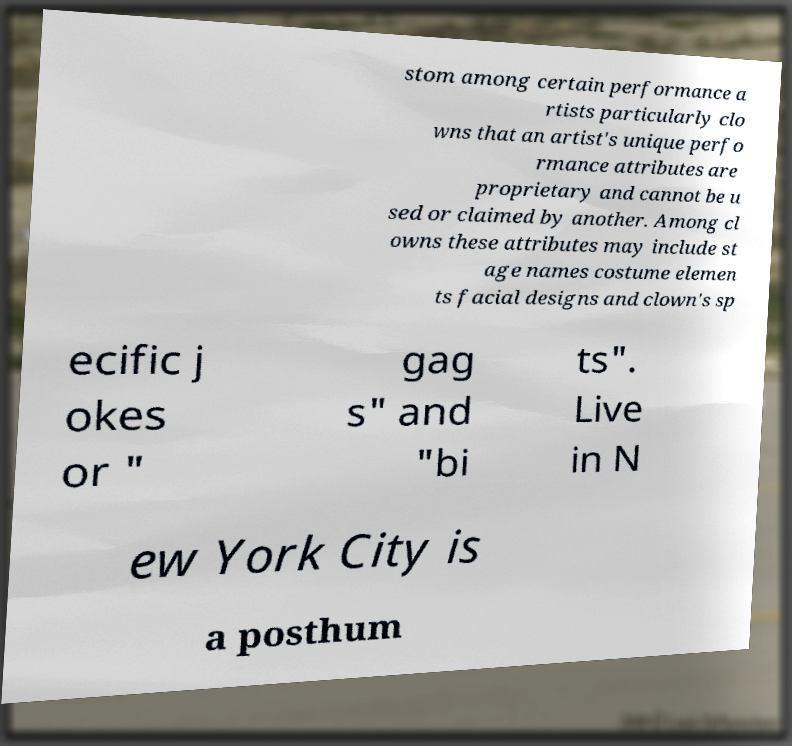Can you accurately transcribe the text from the provided image for me? stom among certain performance a rtists particularly clo wns that an artist's unique perfo rmance attributes are proprietary and cannot be u sed or claimed by another. Among cl owns these attributes may include st age names costume elemen ts facial designs and clown's sp ecific j okes or " gag s" and "bi ts". Live in N ew York City is a posthum 